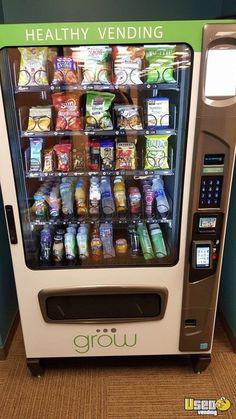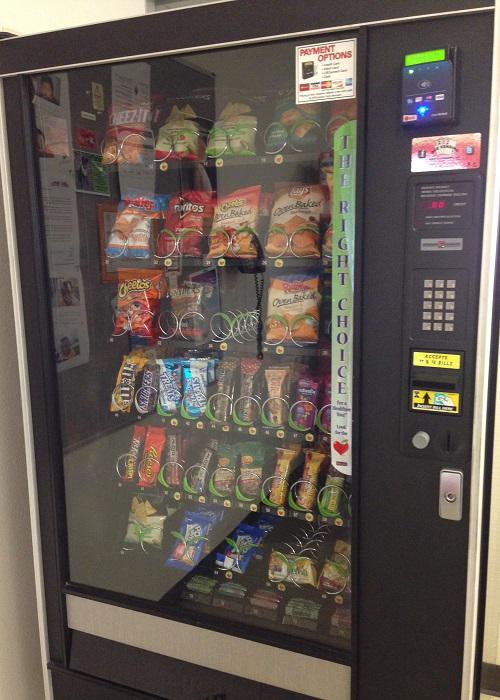The first image is the image on the left, the second image is the image on the right. Given the left and right images, does the statement "The vending machine on the left has green color on its frame." hold true? Answer yes or no. Yes. 